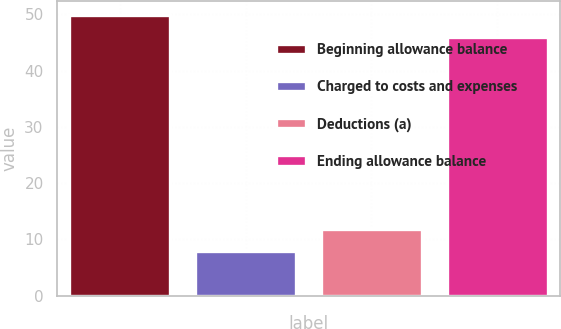<chart> <loc_0><loc_0><loc_500><loc_500><bar_chart><fcel>Beginning allowance balance<fcel>Charged to costs and expenses<fcel>Deductions (a)<fcel>Ending allowance balance<nl><fcel>49.9<fcel>8<fcel>11.9<fcel>46<nl></chart> 